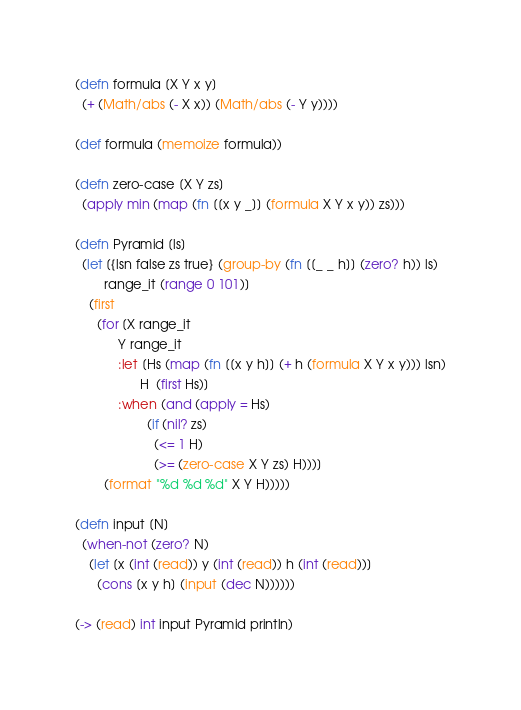<code> <loc_0><loc_0><loc_500><loc_500><_Clojure_>(defn formula [X Y x y]
  (+ (Math/abs (- X x)) (Math/abs (- Y y))))

(def formula (memoize formula))

(defn zero-case [X Y zs]
  (apply min (map (fn [[x y _]] (formula X Y x y)) zs)))

(defn Pyramid [ls]
  (let [{lsn false zs true} (group-by (fn [[_ _ h]] (zero? h)) ls)
        range_it (range 0 101)]
    (first
      (for [X range_it
            Y range_it
            :let [Hs (map (fn [[x y h]] (+ h (formula X Y x y))) lsn)
                  H  (first Hs)]
            :when (and (apply = Hs)
                    (if (nil? zs)
                      (<= 1 H)
                      (>= (zero-case X Y zs) H)))]
        (format "%d %d %d" X Y H)))))

(defn input [N]
  (when-not (zero? N)
    (let [x (int (read)) y (int (read)) h (int (read))]
      (cons [x y h] (input (dec N))))))

(-> (read) int input Pyramid println)</code> 